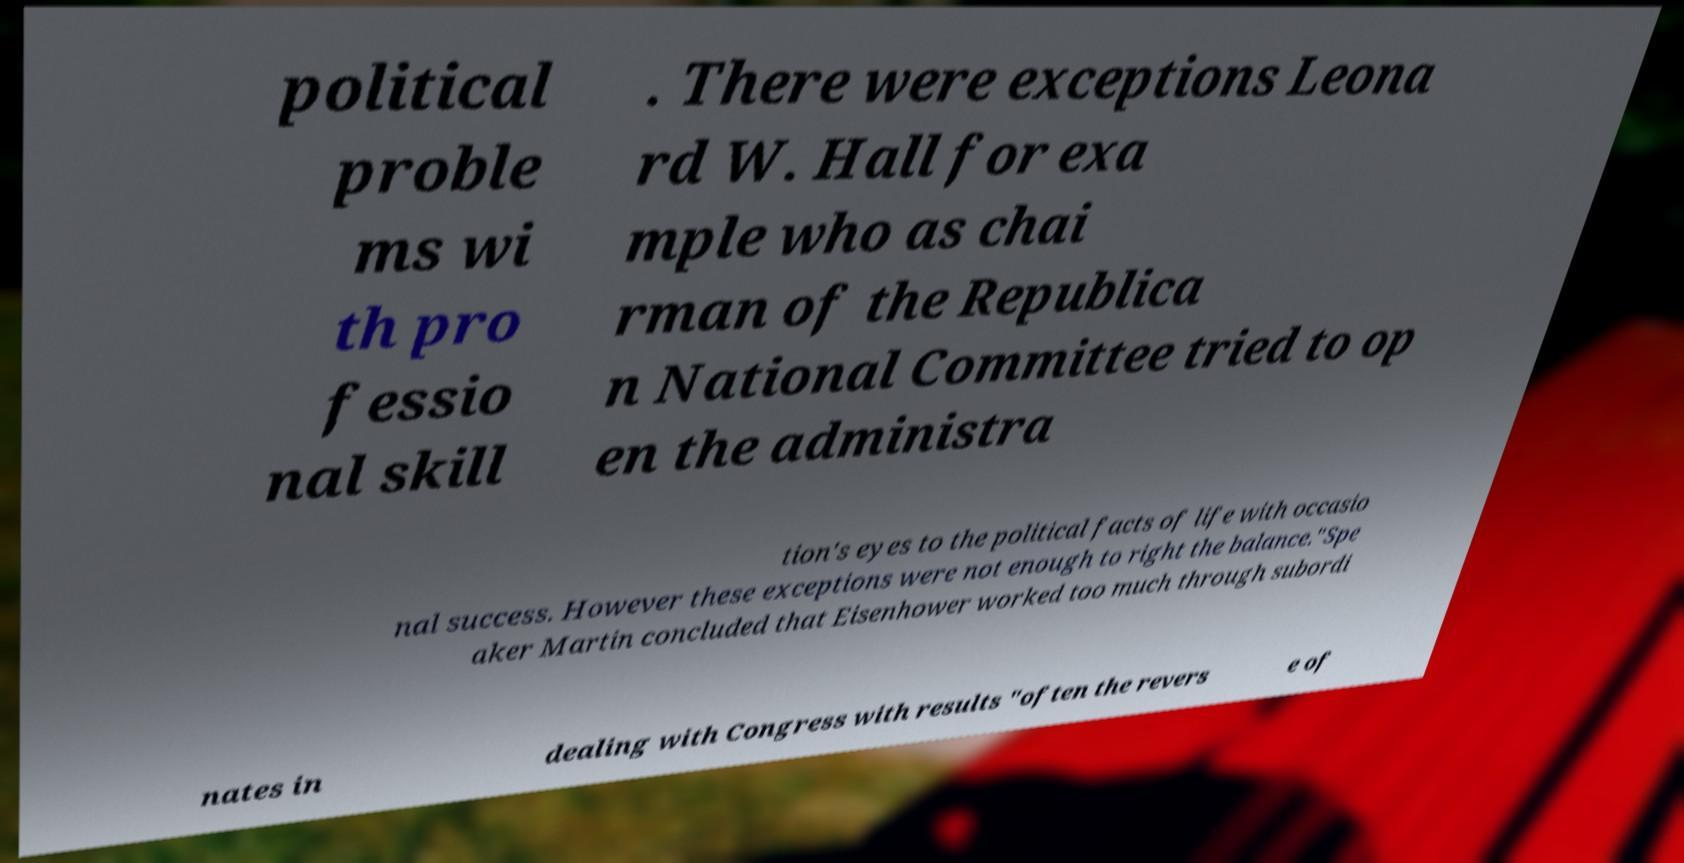Could you extract and type out the text from this image? political proble ms wi th pro fessio nal skill . There were exceptions Leona rd W. Hall for exa mple who as chai rman of the Republica n National Committee tried to op en the administra tion's eyes to the political facts of life with occasio nal success. However these exceptions were not enough to right the balance."Spe aker Martin concluded that Eisenhower worked too much through subordi nates in dealing with Congress with results "often the revers e of 